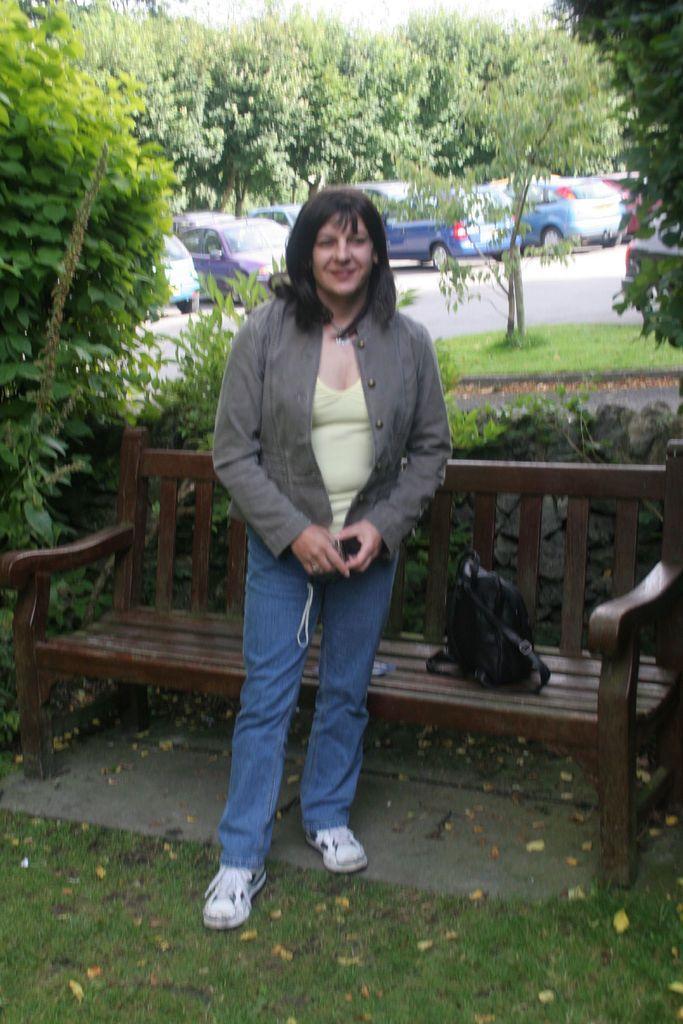Describe this image in one or two sentences. There is a lady standing in front of park bench and some trees are surrounded. 